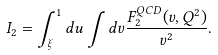<formula> <loc_0><loc_0><loc_500><loc_500>I _ { 2 } = \int _ { \xi } ^ { 1 } d u \int d v \frac { F _ { 2 } ^ { Q C D } ( v , Q ^ { 2 } ) } { v ^ { 2 } } .</formula> 